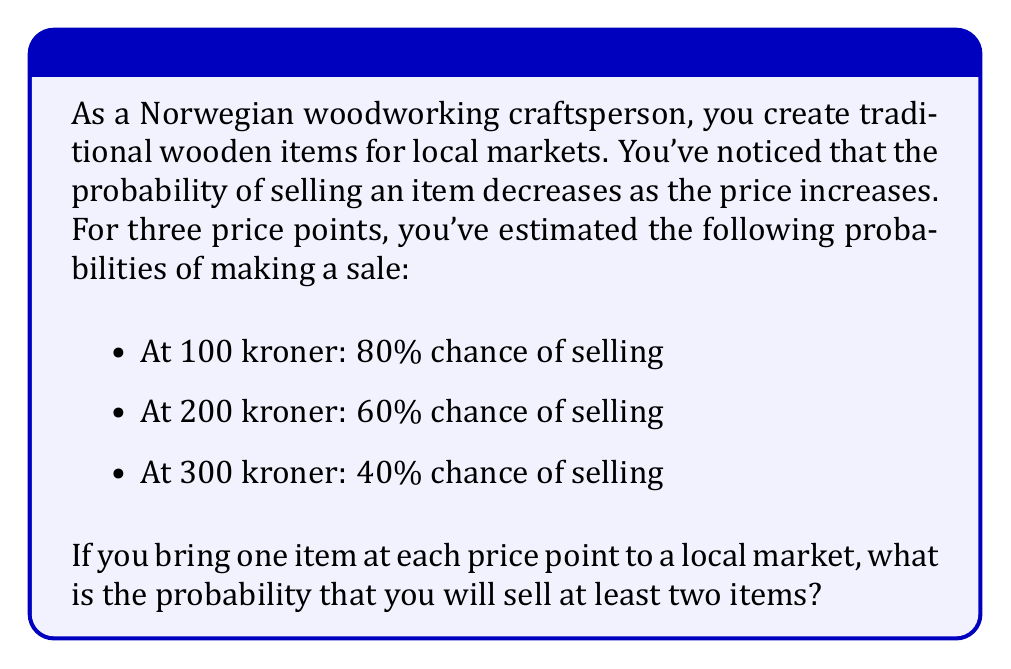Give your solution to this math problem. To solve this problem, we need to use the concept of complementary probability and the multiplication rule for independent events.

Let's approach this step-by-step:

1) First, let's define our events:
   A: Sell the 100 kroner item (P(A) = 0.8)
   B: Sell the 200 kroner item (P(B) = 0.6)
   C: Sell the 300 kroner item (P(C) = 0.4)

2) We want to find the probability of selling at least two items. It's easier to calculate the probability of the complement event: selling fewer than two items (i.e., selling one or zero items).

3) The probability of selling fewer than two items is the sum of:
   - The probability of selling no items
   - The probability of selling exactly one item

4) Probability of selling no items:
   $P(\text{no sales}) = (1-0.8) \times (1-0.6) \times (1-0.4) = 0.2 \times 0.4 \times 0.6 = 0.048$

5) Probability of selling exactly one item:
   - Sell only 100 kroner item: $0.8 \times (1-0.6) \times (1-0.4) = 0.8 \times 0.4 \times 0.6 = 0.192$
   - Sell only 200 kroner item: $(1-0.8) \times 0.6 \times (1-0.4) = 0.2 \times 0.6 \times 0.6 = 0.072$
   - Sell only 300 kroner item: $(1-0.8) \times (1-0.6) \times 0.4 = 0.2 \times 0.4 \times 0.4 = 0.032$

6) Total probability of selling fewer than two items:
   $P(\text{fewer than two}) = 0.048 + 0.192 + 0.072 + 0.032 = 0.344$

7) Therefore, the probability of selling at least two items is:
   $P(\text{at least two}) = 1 - P(\text{fewer than two}) = 1 - 0.344 = 0.656$
Answer: The probability of selling at least two items is 0.656 or 65.6%. 